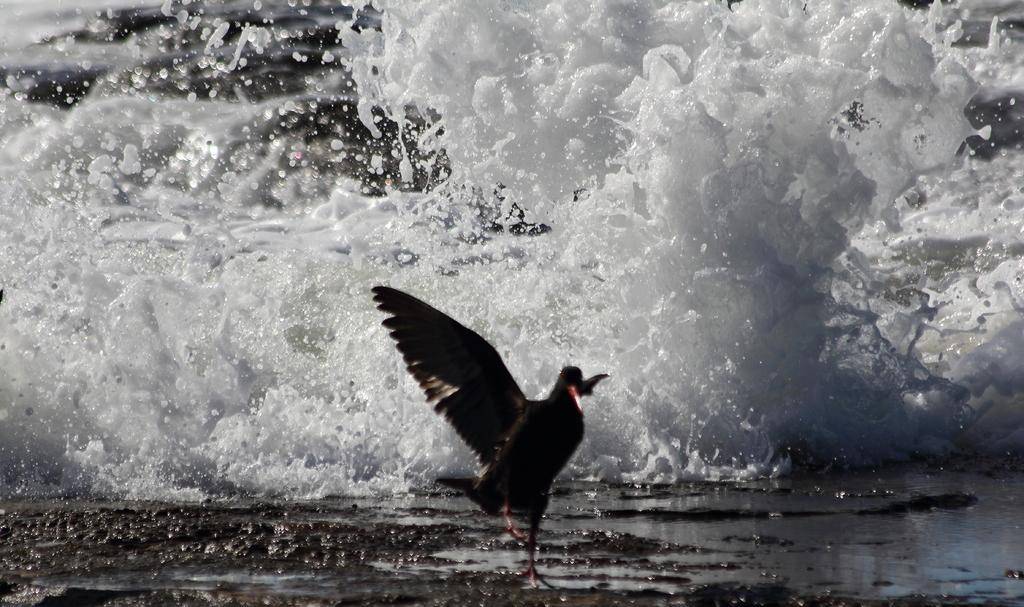What type of surface can be seen in the image? There is ground visible in the image. What animal is present in the image? There is a bird in the image. What colors can be observed on the bird? The bird is black and orange in color. What else is visible in the image besides the ground and the bird? There is water visible in the image. What type of connection can be seen between the bird and the river in the image? There is no river present in the image, and the bird is not connected to any river. How does the cream enhance the appearance of the bird in the image? There is no cream mentioned in the image, and the bird's appearance is already described as black and orange. 